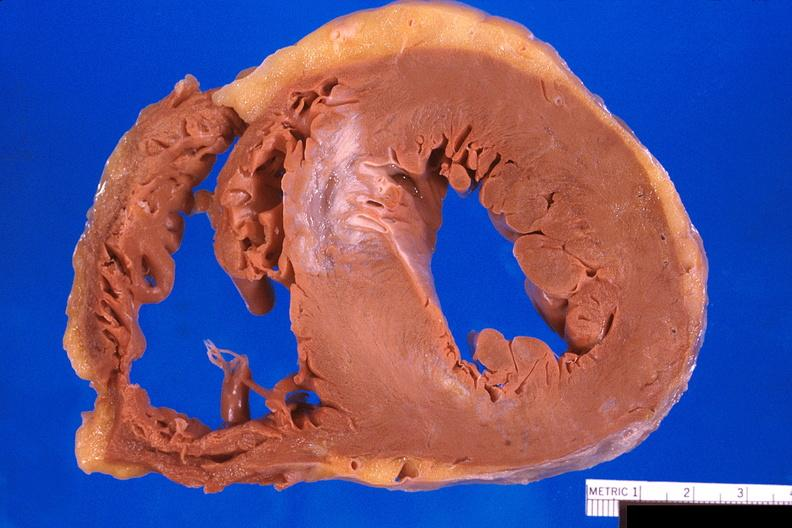what is present?
Answer the question using a single word or phrase. Cardiovascular 